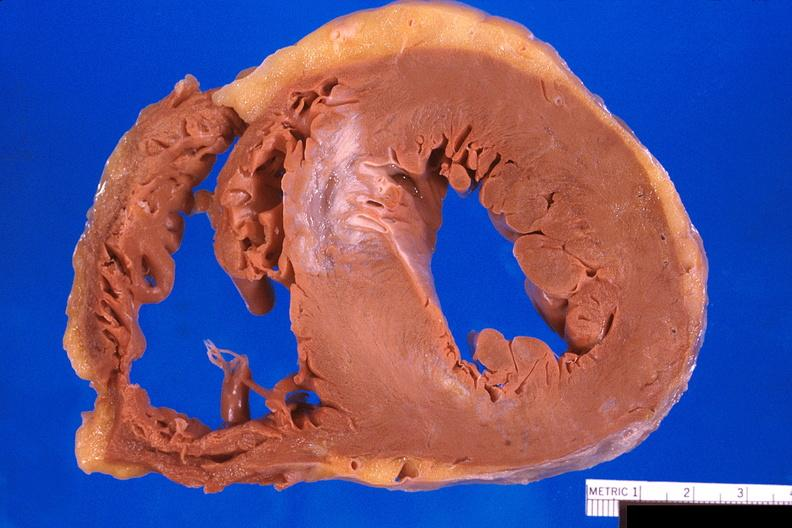what is present?
Answer the question using a single word or phrase. Cardiovascular 